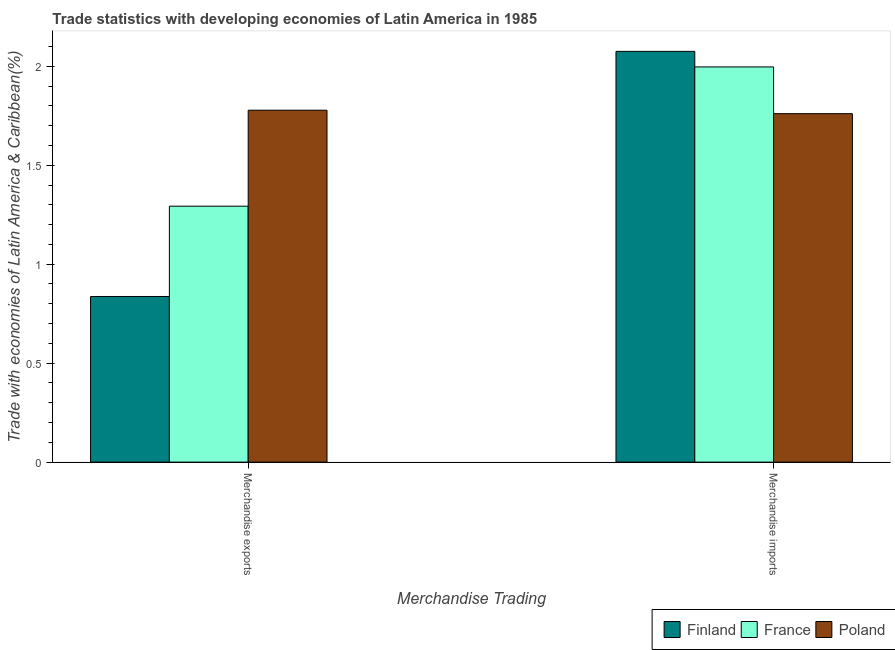How many groups of bars are there?
Ensure brevity in your answer.  2. Are the number of bars on each tick of the X-axis equal?
Your answer should be very brief. Yes. How many bars are there on the 1st tick from the left?
Your answer should be very brief. 3. What is the merchandise imports in France?
Give a very brief answer. 2. Across all countries, what is the maximum merchandise exports?
Keep it short and to the point. 1.78. Across all countries, what is the minimum merchandise imports?
Offer a very short reply. 1.76. In which country was the merchandise imports minimum?
Provide a short and direct response. Poland. What is the total merchandise imports in the graph?
Your response must be concise. 5.83. What is the difference between the merchandise imports in Finland and that in Poland?
Ensure brevity in your answer.  0.31. What is the difference between the merchandise imports in Finland and the merchandise exports in France?
Ensure brevity in your answer.  0.78. What is the average merchandise imports per country?
Offer a very short reply. 1.94. What is the difference between the merchandise exports and merchandise imports in Finland?
Provide a short and direct response. -1.24. In how many countries, is the merchandise imports greater than 1.9 %?
Give a very brief answer. 2. What is the ratio of the merchandise imports in Finland to that in France?
Keep it short and to the point. 1.04. Is the merchandise exports in France less than that in Finland?
Offer a very short reply. No. In how many countries, is the merchandise exports greater than the average merchandise exports taken over all countries?
Provide a succinct answer. 1. What does the 1st bar from the left in Merchandise imports represents?
Offer a very short reply. Finland. What does the 2nd bar from the right in Merchandise imports represents?
Give a very brief answer. France. Does the graph contain any zero values?
Keep it short and to the point. No. Where does the legend appear in the graph?
Provide a short and direct response. Bottom right. How many legend labels are there?
Give a very brief answer. 3. How are the legend labels stacked?
Offer a very short reply. Horizontal. What is the title of the graph?
Give a very brief answer. Trade statistics with developing economies of Latin America in 1985. Does "Cuba" appear as one of the legend labels in the graph?
Offer a terse response. No. What is the label or title of the X-axis?
Provide a succinct answer. Merchandise Trading. What is the label or title of the Y-axis?
Your answer should be very brief. Trade with economies of Latin America & Caribbean(%). What is the Trade with economies of Latin America & Caribbean(%) of Finland in Merchandise exports?
Make the answer very short. 0.84. What is the Trade with economies of Latin America & Caribbean(%) of France in Merchandise exports?
Your response must be concise. 1.29. What is the Trade with economies of Latin America & Caribbean(%) of Poland in Merchandise exports?
Provide a succinct answer. 1.78. What is the Trade with economies of Latin America & Caribbean(%) of Finland in Merchandise imports?
Your response must be concise. 2.08. What is the Trade with economies of Latin America & Caribbean(%) in France in Merchandise imports?
Offer a very short reply. 2. What is the Trade with economies of Latin America & Caribbean(%) of Poland in Merchandise imports?
Your answer should be very brief. 1.76. Across all Merchandise Trading, what is the maximum Trade with economies of Latin America & Caribbean(%) of Finland?
Your response must be concise. 2.08. Across all Merchandise Trading, what is the maximum Trade with economies of Latin America & Caribbean(%) of France?
Give a very brief answer. 2. Across all Merchandise Trading, what is the maximum Trade with economies of Latin America & Caribbean(%) of Poland?
Your answer should be very brief. 1.78. Across all Merchandise Trading, what is the minimum Trade with economies of Latin America & Caribbean(%) of Finland?
Your answer should be compact. 0.84. Across all Merchandise Trading, what is the minimum Trade with economies of Latin America & Caribbean(%) in France?
Give a very brief answer. 1.29. Across all Merchandise Trading, what is the minimum Trade with economies of Latin America & Caribbean(%) of Poland?
Provide a succinct answer. 1.76. What is the total Trade with economies of Latin America & Caribbean(%) in Finland in the graph?
Make the answer very short. 2.91. What is the total Trade with economies of Latin America & Caribbean(%) of France in the graph?
Provide a succinct answer. 3.29. What is the total Trade with economies of Latin America & Caribbean(%) in Poland in the graph?
Provide a succinct answer. 3.54. What is the difference between the Trade with economies of Latin America & Caribbean(%) of Finland in Merchandise exports and that in Merchandise imports?
Provide a succinct answer. -1.24. What is the difference between the Trade with economies of Latin America & Caribbean(%) of France in Merchandise exports and that in Merchandise imports?
Provide a succinct answer. -0.7. What is the difference between the Trade with economies of Latin America & Caribbean(%) of Poland in Merchandise exports and that in Merchandise imports?
Your response must be concise. 0.02. What is the difference between the Trade with economies of Latin America & Caribbean(%) of Finland in Merchandise exports and the Trade with economies of Latin America & Caribbean(%) of France in Merchandise imports?
Ensure brevity in your answer.  -1.16. What is the difference between the Trade with economies of Latin America & Caribbean(%) of Finland in Merchandise exports and the Trade with economies of Latin America & Caribbean(%) of Poland in Merchandise imports?
Ensure brevity in your answer.  -0.92. What is the difference between the Trade with economies of Latin America & Caribbean(%) of France in Merchandise exports and the Trade with economies of Latin America & Caribbean(%) of Poland in Merchandise imports?
Ensure brevity in your answer.  -0.47. What is the average Trade with economies of Latin America & Caribbean(%) in Finland per Merchandise Trading?
Offer a terse response. 1.46. What is the average Trade with economies of Latin America & Caribbean(%) of France per Merchandise Trading?
Offer a very short reply. 1.64. What is the average Trade with economies of Latin America & Caribbean(%) of Poland per Merchandise Trading?
Your answer should be very brief. 1.77. What is the difference between the Trade with economies of Latin America & Caribbean(%) of Finland and Trade with economies of Latin America & Caribbean(%) of France in Merchandise exports?
Offer a very short reply. -0.46. What is the difference between the Trade with economies of Latin America & Caribbean(%) of Finland and Trade with economies of Latin America & Caribbean(%) of Poland in Merchandise exports?
Make the answer very short. -0.94. What is the difference between the Trade with economies of Latin America & Caribbean(%) in France and Trade with economies of Latin America & Caribbean(%) in Poland in Merchandise exports?
Offer a very short reply. -0.48. What is the difference between the Trade with economies of Latin America & Caribbean(%) in Finland and Trade with economies of Latin America & Caribbean(%) in France in Merchandise imports?
Offer a very short reply. 0.08. What is the difference between the Trade with economies of Latin America & Caribbean(%) of Finland and Trade with economies of Latin America & Caribbean(%) of Poland in Merchandise imports?
Offer a terse response. 0.31. What is the difference between the Trade with economies of Latin America & Caribbean(%) of France and Trade with economies of Latin America & Caribbean(%) of Poland in Merchandise imports?
Offer a very short reply. 0.24. What is the ratio of the Trade with economies of Latin America & Caribbean(%) of Finland in Merchandise exports to that in Merchandise imports?
Offer a terse response. 0.4. What is the ratio of the Trade with economies of Latin America & Caribbean(%) of France in Merchandise exports to that in Merchandise imports?
Provide a short and direct response. 0.65. What is the ratio of the Trade with economies of Latin America & Caribbean(%) of Poland in Merchandise exports to that in Merchandise imports?
Offer a terse response. 1.01. What is the difference between the highest and the second highest Trade with economies of Latin America & Caribbean(%) of Finland?
Make the answer very short. 1.24. What is the difference between the highest and the second highest Trade with economies of Latin America & Caribbean(%) in France?
Your answer should be very brief. 0.7. What is the difference between the highest and the second highest Trade with economies of Latin America & Caribbean(%) in Poland?
Provide a short and direct response. 0.02. What is the difference between the highest and the lowest Trade with economies of Latin America & Caribbean(%) of Finland?
Offer a very short reply. 1.24. What is the difference between the highest and the lowest Trade with economies of Latin America & Caribbean(%) in France?
Give a very brief answer. 0.7. What is the difference between the highest and the lowest Trade with economies of Latin America & Caribbean(%) of Poland?
Offer a terse response. 0.02. 